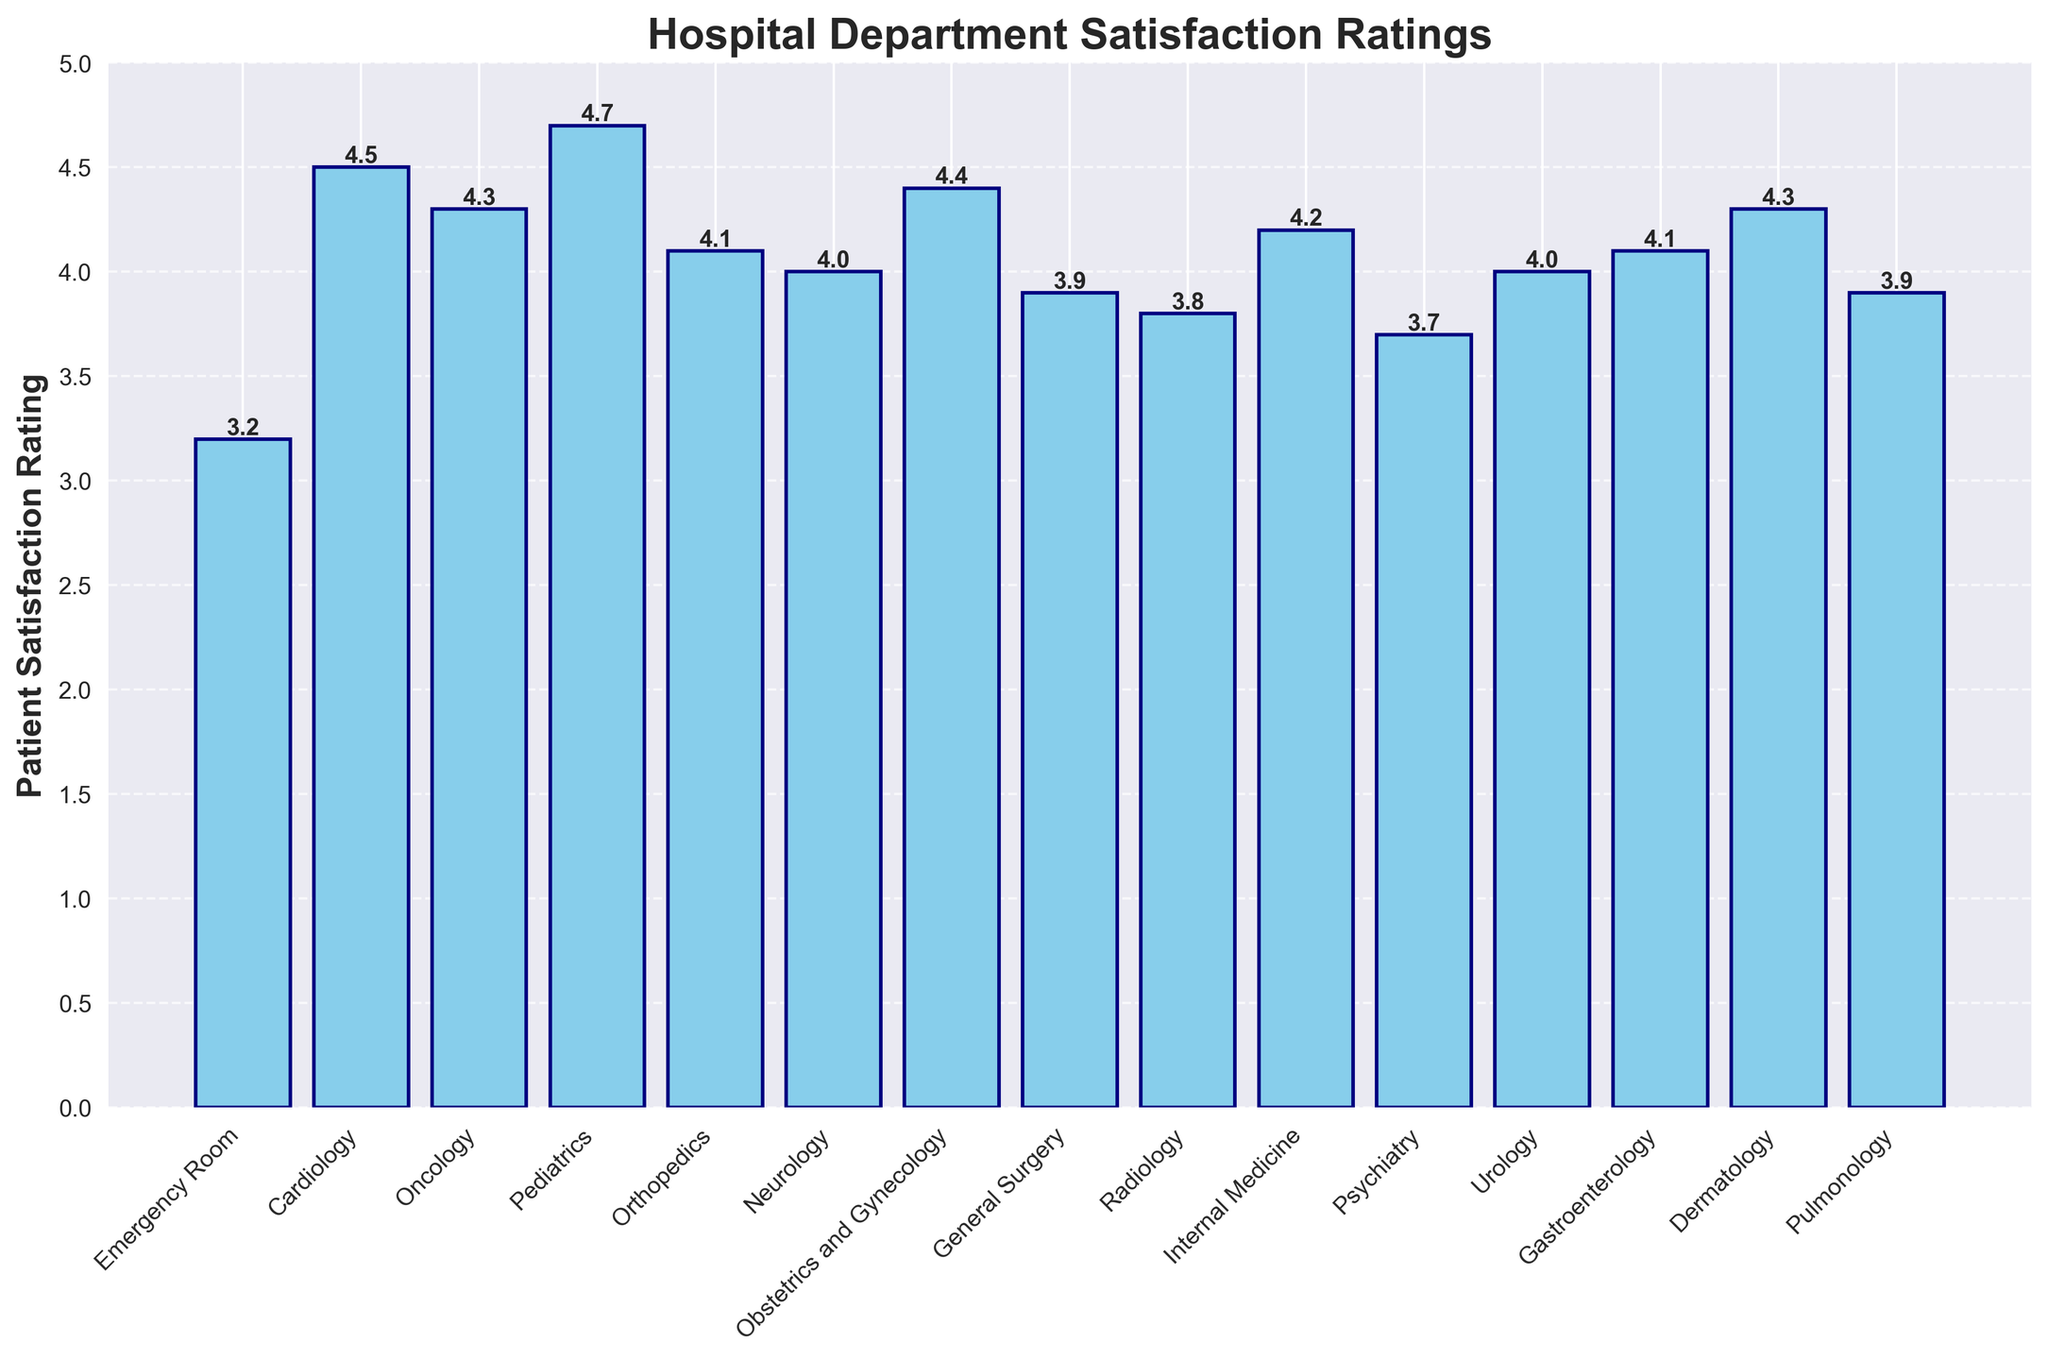Which department has the highest patient satisfaction rating? The highest bar in the chart indicates the department with the highest rating. Pediatrics has the highest bar with a rating of 4.7.
Answer: Pediatrics Which department has the lowest patient satisfaction rating? The lowest bar in the chart indicates the department with the lowest rating. The Emergency Room has the lowest bar with a rating of 3.2.
Answer: Emergency Room Which departments have a patient satisfaction rating of 4.0? Locate all the bars with a height of 4.0. Neurology and Urology both have bars with a height of 4.0.
Answer: Neurology, Urology What is the difference in patient satisfaction ratings between Pediatrics and the Emergency Room? Pediatrics has a rating of 4.7, and the Emergency Room has a rating of 3.2. The difference between these ratings is 4.7 - 3.2.
Answer: 1.5 What is the average patient satisfaction rating across all departments? Sum all department ratings and divide by the number of departments. (3.2 + 4.5 + 4.3 + 4.7 + 4.1 + 4.0 + 4.4 + 3.9 + 3.8 + 4.2 + 3.7 + 4.0 + 4.1 + 4.3 + 3.9) / 15 = 60.1 / 15 = 4.01
Answer: 4.01 How many departments have a patient satisfaction rating higher than 4? Count all bars with a height greater than 4.0. There are ten bars with ratings higher than 4.0: Cardiology, Oncology, Pediatrics, Orthopedics, Obstetrics and Gynecology, Internal Medicine, Dermatology, Neurology, Urology, Gastroenterology.
Answer: 10 What is the total patient satisfaction rating for General Surgery and Radiology combined? Add the ratings for General Surgery and Radiology. 3.9 (General Surgery) + 3.8 (Radiology) = 7.7
Answer: 7.7 Which department has a patient satisfaction rating of 3.7? Locate the bar with a height of 3.7. Psychiatry has a rating of 3.7.
Answer: Psychiatry Which are the three departments with the highest patient satisfaction ratings? Identify the three highest bars. Pediatrics (4.7), Cardiology (4.5), and Oncology & Dermatology (4.3).
Answer: Pediatrics, Cardiology, Oncology, Dermatology What is the visual pattern for the bar colors in the figure? All bars are colored sky blue with navy edges, as described in the code, creating a consistent color scheme throughout the chart.
Answer: Sky blue with navy edges 